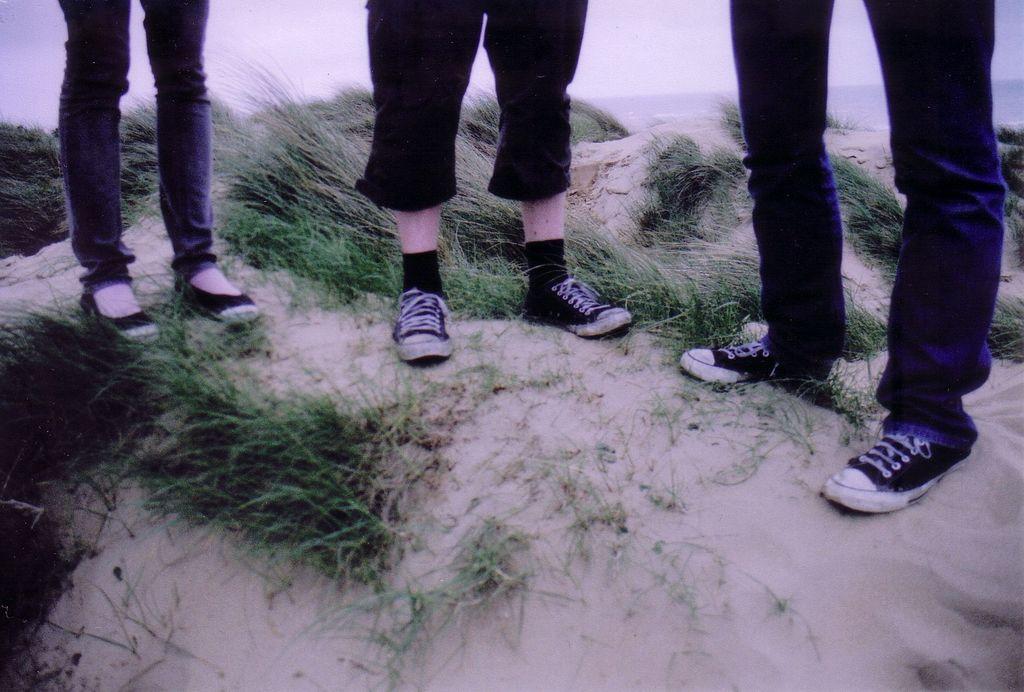Could you give a brief overview of what you see in this image? This image is taken outdoors. At the bottom of the image there is a ground with grass on it. At the top of the image there is a sky with clouds. In the middle of the image three people are standing on the ground. 